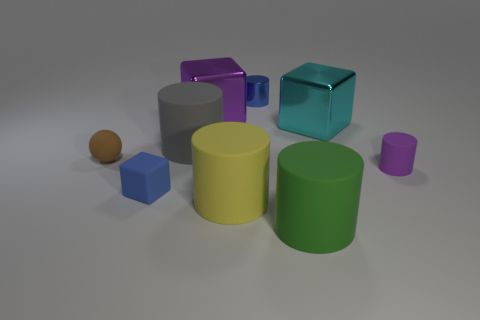There is another block that is the same material as the large purple block; what is its size? The block that appears to be made of the same shiny, reflective material as the large purple block is the teal cube. Its size is medium compared to the other shapes in the image, notably smaller than the large purple block but similarly proportioned. 